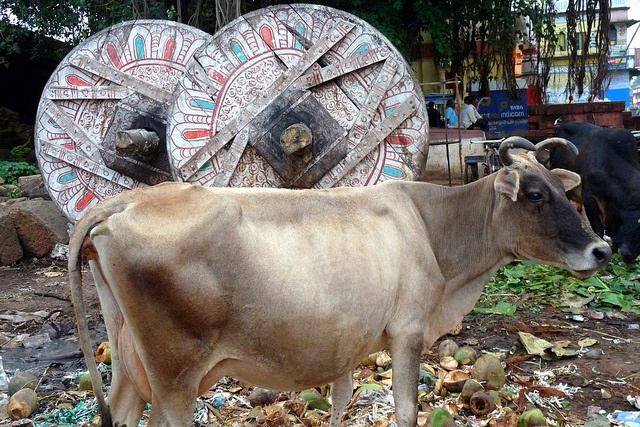Describe the objects in this image and their specific colors. I can see cow in blue, gray, darkgray, and maroon tones, people in blue, black, darkgray, and gray tones, people in blue, black, teal, and gray tones, and people in blue, black, olive, and gray tones in this image. 